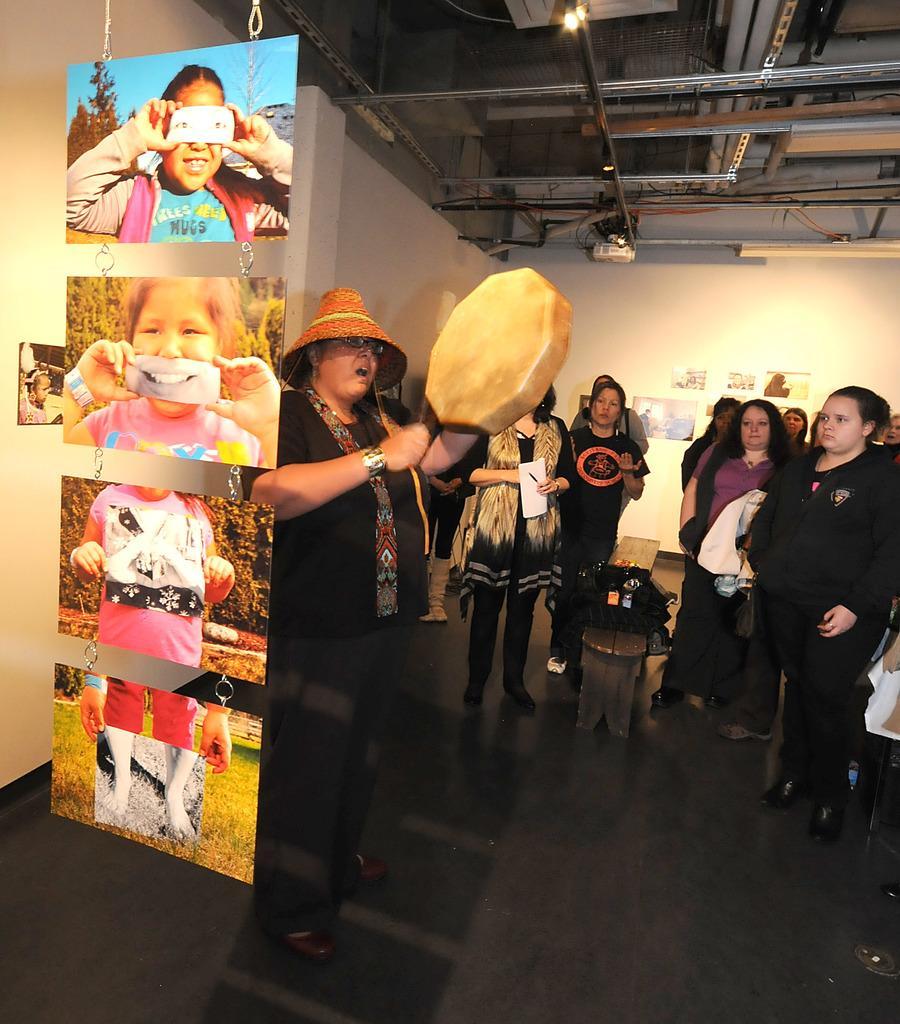In one or two sentences, can you explain what this image depicts? In this picture we can see a group of women standing in the hall. In the front we can see a woman, standing and holding the drum in the hand. On the left corner we can see some hanging photo posters. On the top we can see iron frames on the ceiling. 